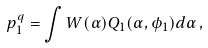Convert formula to latex. <formula><loc_0><loc_0><loc_500><loc_500>p _ { 1 } ^ { q } = \int W ( \alpha ) Q _ { 1 } ( \alpha , \phi _ { 1 } ) d \alpha \, ,</formula> 